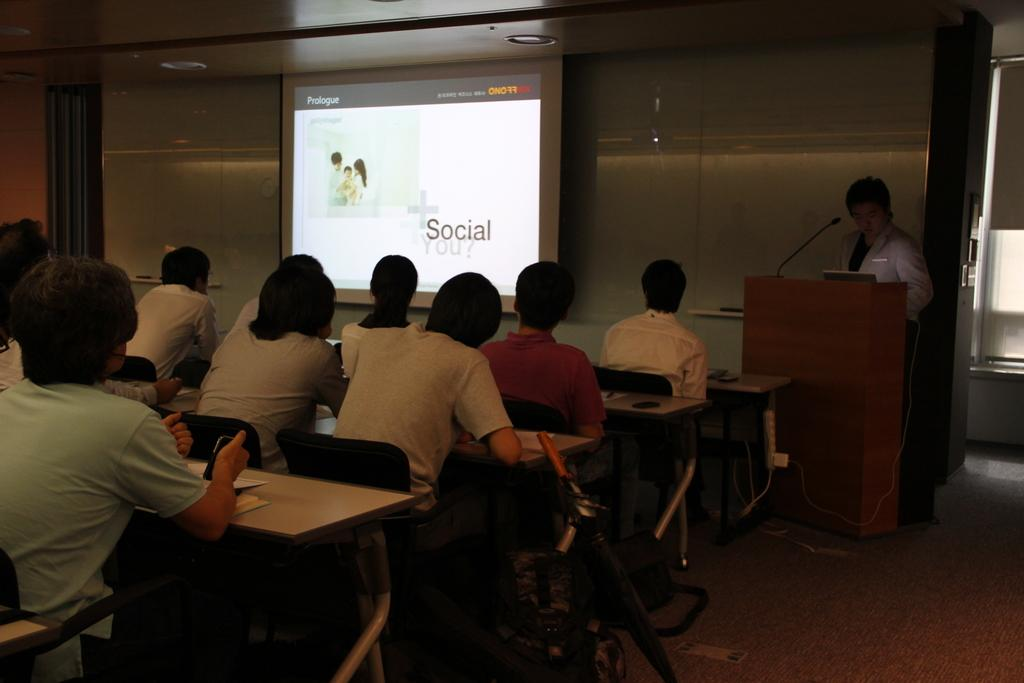What is the man near in the image? The man is standing near a podium in the image. What can be seen on the podium? There is a microphone (mike) on the podium in the image. What are the people in front of the table doing? The persons sitting on chairs in front of a table are likely listening or participating in an event. What is the surface visible in the image? The image shows a floor. What type of fuel is being used by the brass quince in the image? There is no fuel, brass, or quince present in the image. 